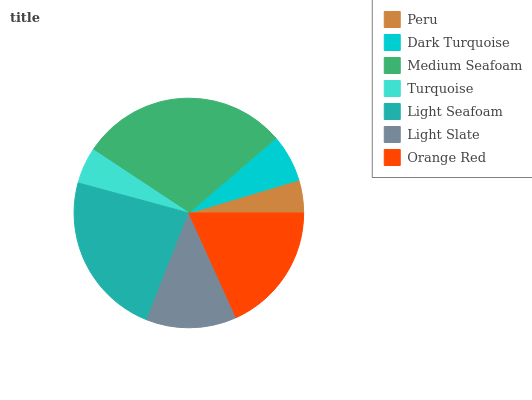Is Peru the minimum?
Answer yes or no. Yes. Is Medium Seafoam the maximum?
Answer yes or no. Yes. Is Dark Turquoise the minimum?
Answer yes or no. No. Is Dark Turquoise the maximum?
Answer yes or no. No. Is Dark Turquoise greater than Peru?
Answer yes or no. Yes. Is Peru less than Dark Turquoise?
Answer yes or no. Yes. Is Peru greater than Dark Turquoise?
Answer yes or no. No. Is Dark Turquoise less than Peru?
Answer yes or no. No. Is Light Slate the high median?
Answer yes or no. Yes. Is Light Slate the low median?
Answer yes or no. Yes. Is Dark Turquoise the high median?
Answer yes or no. No. Is Peru the low median?
Answer yes or no. No. 